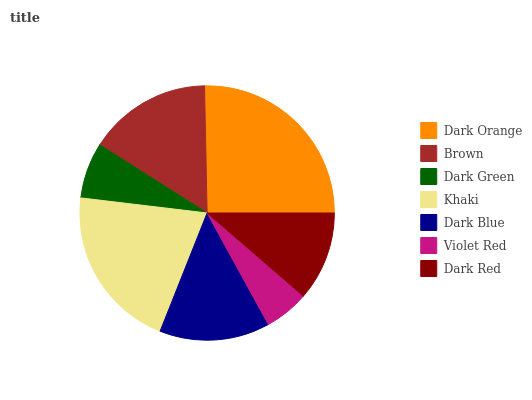Is Violet Red the minimum?
Answer yes or no. Yes. Is Dark Orange the maximum?
Answer yes or no. Yes. Is Brown the minimum?
Answer yes or no. No. Is Brown the maximum?
Answer yes or no. No. Is Dark Orange greater than Brown?
Answer yes or no. Yes. Is Brown less than Dark Orange?
Answer yes or no. Yes. Is Brown greater than Dark Orange?
Answer yes or no. No. Is Dark Orange less than Brown?
Answer yes or no. No. Is Dark Blue the high median?
Answer yes or no. Yes. Is Dark Blue the low median?
Answer yes or no. Yes. Is Dark Green the high median?
Answer yes or no. No. Is Violet Red the low median?
Answer yes or no. No. 